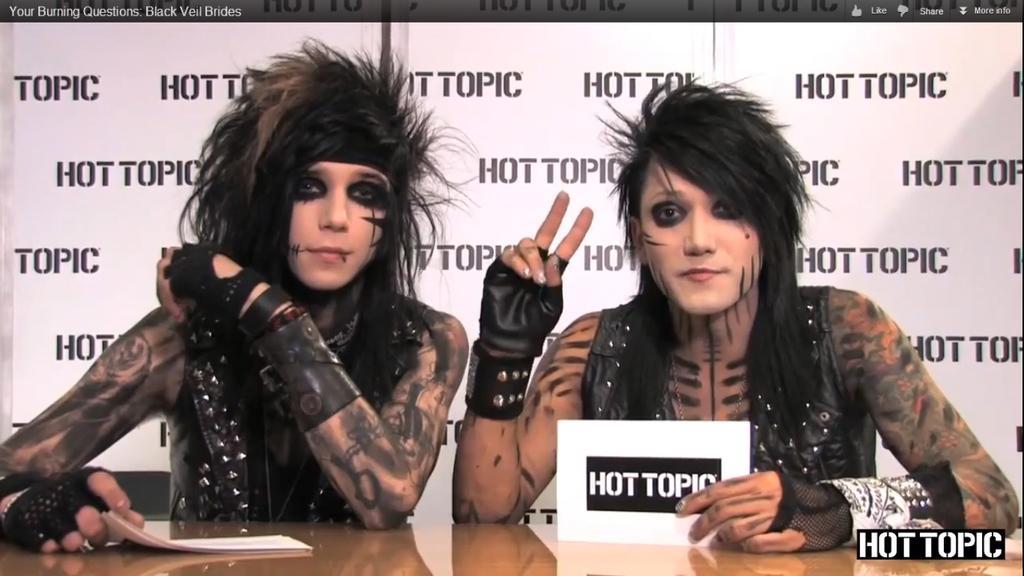Could you give a brief overview of what you see in this image? In this image I can see two people in-front of the table. These people are holding the papers. On the paper I can see the name hot topic is written on it. These people are wearing the black color dresses. In the background I can see the banner which is in black color. 